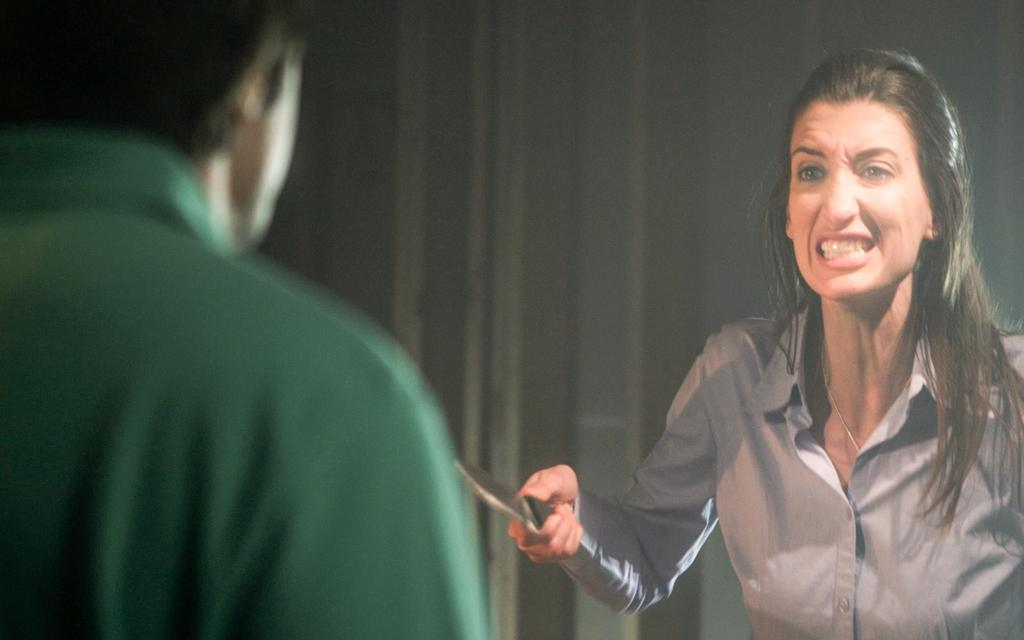What is the person in the image doing? The person is standing and holding a knife in the image. Can you describe the man on the left side of the image? There is a man on the left side of the image, but no specific details about him are provided. What can be seen in the background of the image? There is a wall in the background of the image. How many ants can be seen crawling on the sofa in the image? There is no sofa or ants present in the image. What type of expansion is occurring in the image? There is no expansion occurring in the image; it features a person holding a knife and a man on the left side of the image. 